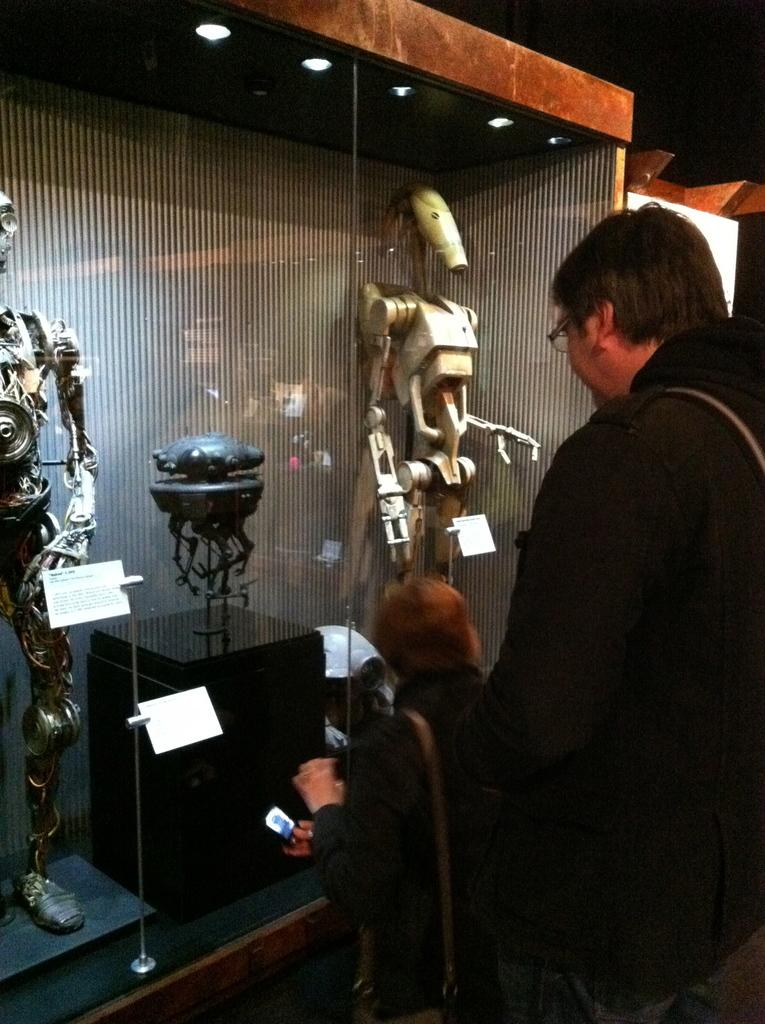What is the main subject in the image? There is a man standing in the image. What other subjects can be seen in the image? There are robots and other objects in the image. Can you describe the lighting in the image? Lights are visible in the image. What type of architectural feature is present in the image? There is a glass wall in the image. What type of linen is being ironed in the image? There is no linen or iron present in the image. Can you describe the spark generated by the robots in the image? There are no sparks generated by the robots in the image. 